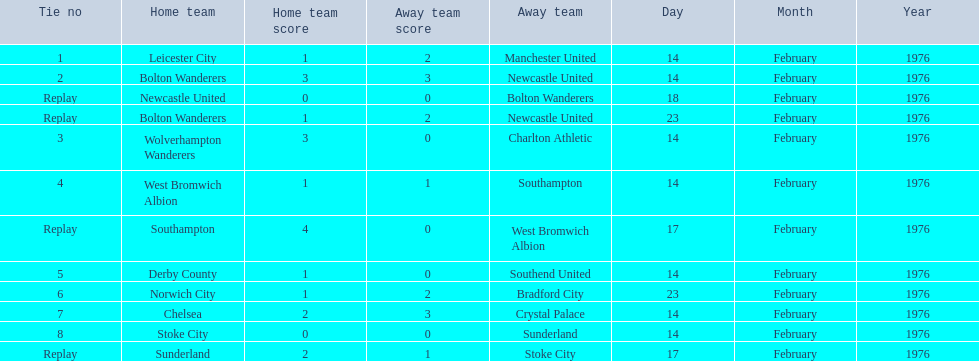What were the home teams in the 1975-76 fa cup? Leicester City, Bolton Wanderers, Newcastle United, Bolton Wanderers, Wolverhampton Wanderers, West Bromwich Albion, Southampton, Derby County, Norwich City, Chelsea, Stoke City, Sunderland. Which of these teams had the tie number 1? Leicester City. 